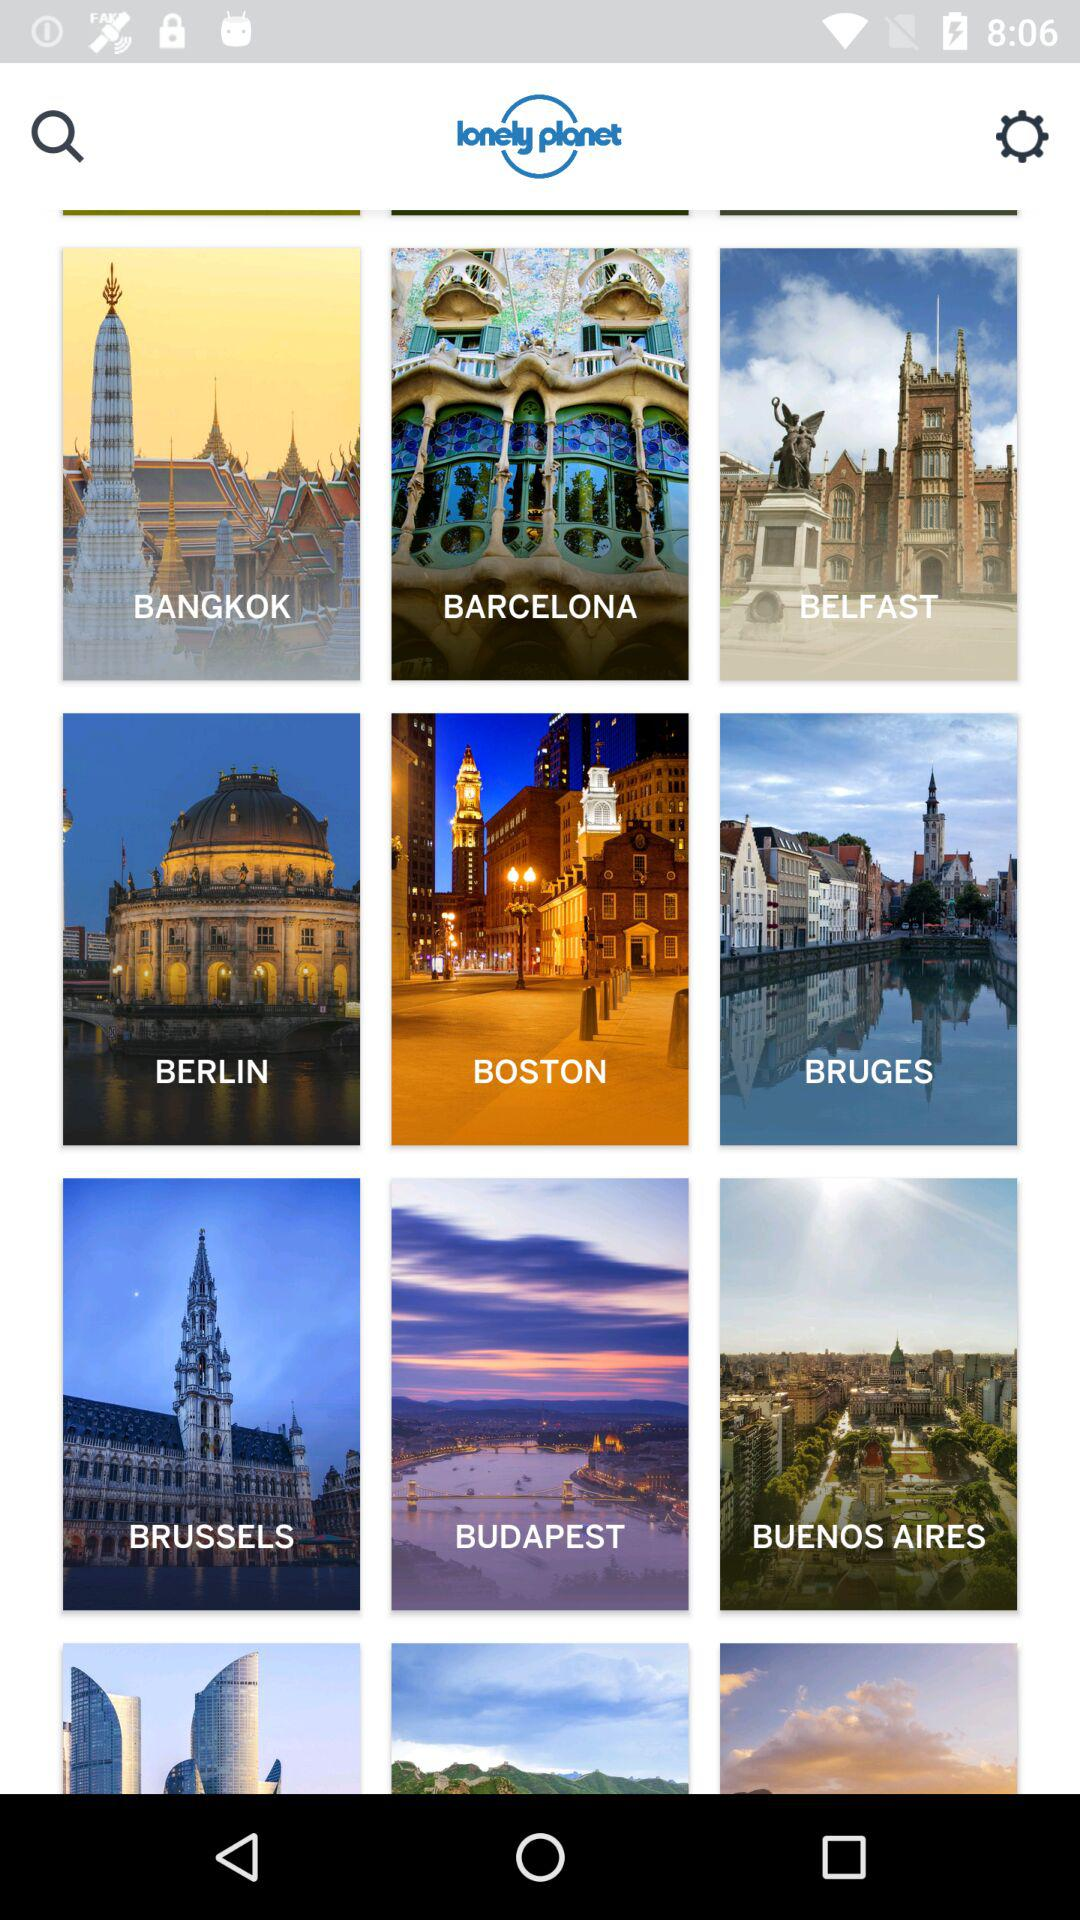Where are the lonely planets?
When the provided information is insufficient, respond with <no answer>. <no answer> 